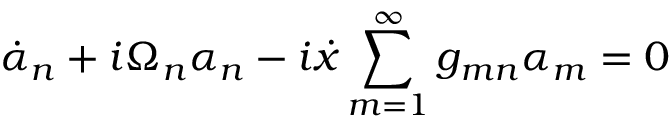Convert formula to latex. <formula><loc_0><loc_0><loc_500><loc_500>\dot { \alpha } _ { n } + i \Omega _ { n } \alpha _ { n } - i \dot { x } \sum _ { m = 1 } ^ { \infty } g _ { m n } \alpha _ { m } = 0</formula> 